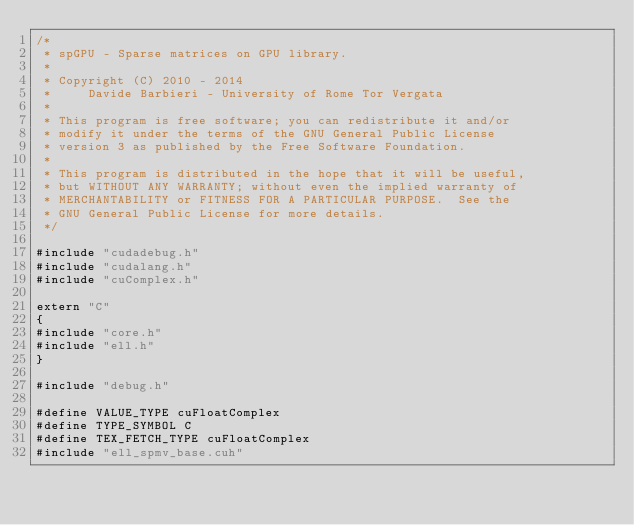Convert code to text. <code><loc_0><loc_0><loc_500><loc_500><_Cuda_>/*
 * spGPU - Sparse matrices on GPU library.
 * 
 * Copyright (C) 2010 - 2014
 *     Davide Barbieri - University of Rome Tor Vergata
 *
 * This program is free software; you can redistribute it and/or
 * modify it under the terms of the GNU General Public License
 * version 3 as published by the Free Software Foundation.
 *
 * This program is distributed in the hope that it will be useful,
 * but WITHOUT ANY WARRANTY; without even the implied warranty of
 * MERCHANTABILITY or FITNESS FOR A PARTICULAR PURPOSE.  See the
 * GNU General Public License for more details.
 */
 
#include "cudadebug.h"
#include "cudalang.h"
#include "cuComplex.h"

extern "C"
{
#include "core.h"
#include "ell.h"
}

#include "debug.h"

#define VALUE_TYPE cuFloatComplex
#define TYPE_SYMBOL C
#define TEX_FETCH_TYPE cuFloatComplex
#include "ell_spmv_base.cuh"

</code> 